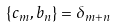<formula> <loc_0><loc_0><loc_500><loc_500>\{ c _ { m } , b _ { n } \} = \delta _ { m + n }</formula> 